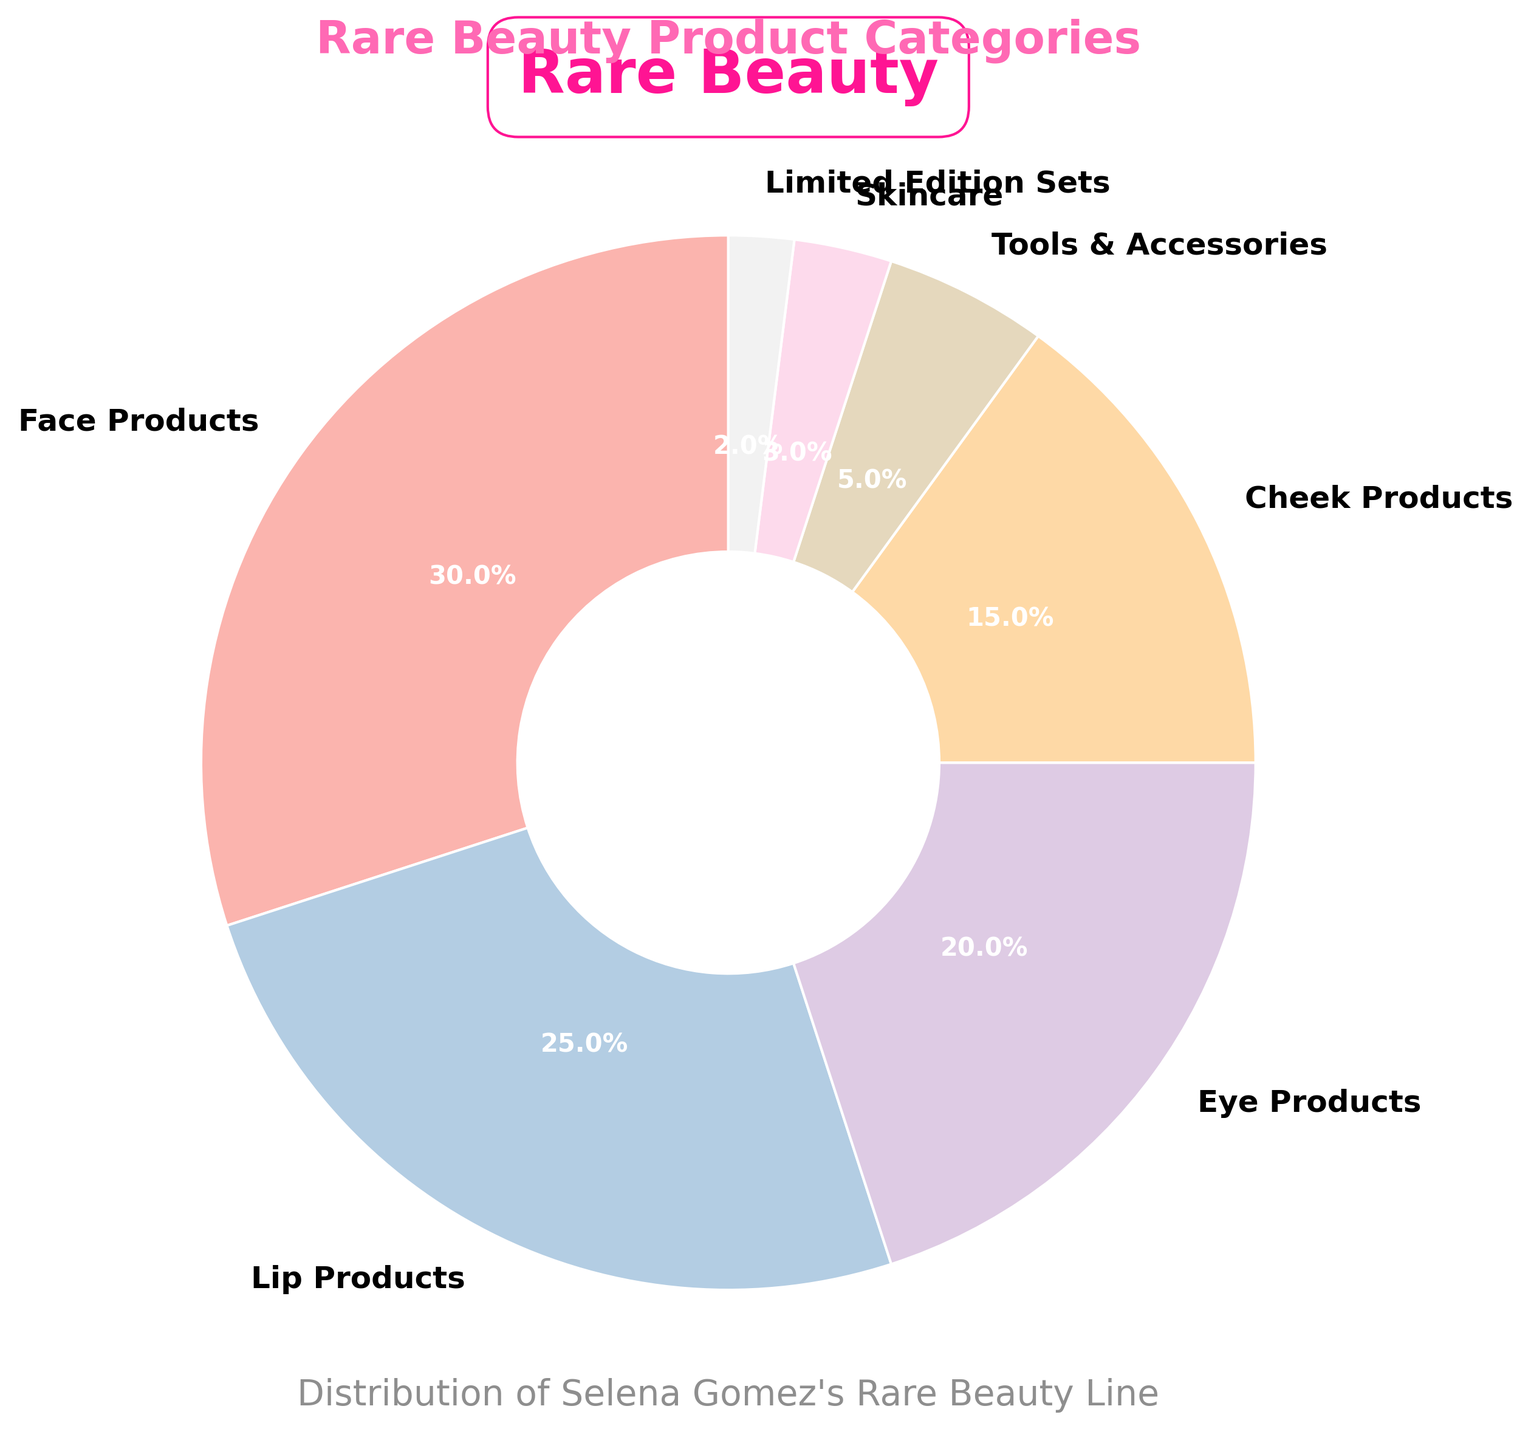What percentage of Rare Beauty products fall under the Cheek Products category? The Cheek Products category is represented by one of the segments in the pie chart. By looking at the percentage label near the respective segment, we can see the percentage of Cheek Products.
Answer: 15% Which category has a higher percentage, Tools & Accessories or Limited Edition Sets? To answer this, we need to look at the percentage labels for both Tools & Accessories and Limited Edition Sets. Tools & Accessories is 5%, while Limited Edition Sets is 2%.
Answer: Tools & Accessories What is the total percentage of Face Products and Lip Products combined? First, find the percentages for Face Products and Lip Products from the pie chart. Face Products is 30%, and Lip Products is 25%. Adding these two percentages gives 30% + 25% = 55%.
Answer: 55% Which category represents the smallest portion of the pie chart? To find the smallest portion, we compare the percentage labels for all categories. Limited Edition Sets has the smallest percentage, 2%.
Answer: Limited Edition Sets Are Eye Products and Skincare combined more, less, or equal to Face Products alone? Eye Products represent 20%, and Skincare represents 3%. Summing them up gives 20% + 3% = 23%. Comparing this with Face Products, which is 30%, we see that 23% is less than 30%.
Answer: Less Which product category is represented by the most prominent color in the pie chart? The most prominent color usually indicates the largest section in the pie chart. By identifying the largest section, we see it’s the section representing Face Products, which is 30%.
Answer: Face Products What is the ratio of Lip Products to Eye Products in the pie chart? The percentage of Lip Products is 25%, and Eye Products is 20%. The ratio is calculated as 25:20, which simplifies to 5:4.
Answer: 5:4 If we added another category with 10%, how would the Cheek Products' share visually compare? Currently, Cheek Products are at 15%. Adding a new category with 10% would reduce other segments proportionally. After adding 10%, Cheek Products would still be larger than the new category because 15% is greater than 10%.
Answer: Cheek Products would still be larger How many categories have a percentage greater than or equal to 20%? From the pie chart, we identify Face Products (30%), Lip Products (25%), and Eye Products (20%) as those with percentages greater than or equal to 20%.
Answer: 3 If the Tools & Accessories and Skincare categories were combined, what would their combined percentage be, and would this new category be larger than Cheek Products? Tools & Accessories is 5%, and Skincare is 3%. Their combined percentage is 5% + 3% = 8%. Comparing 8% with Cheek Products at 15%, 8% is less than 15%.
Answer: 8%, No 